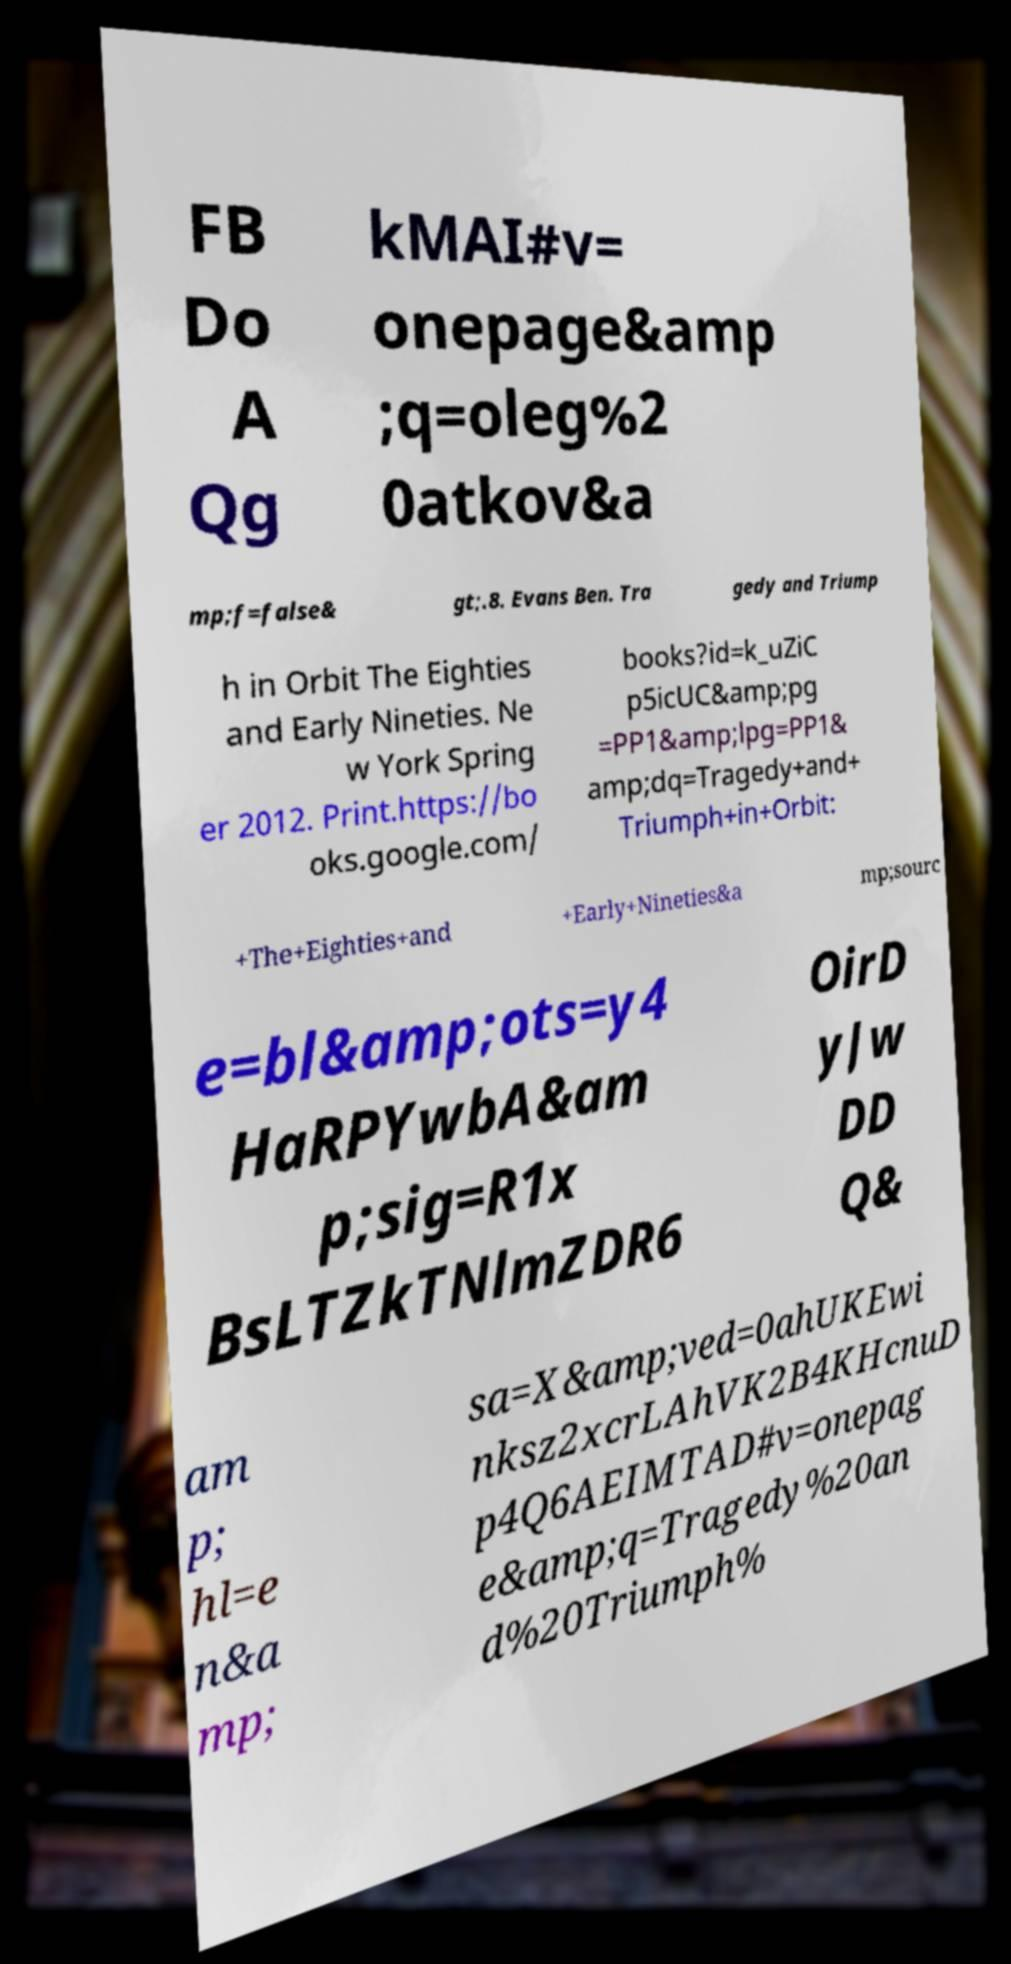Can you read and provide the text displayed in the image?This photo seems to have some interesting text. Can you extract and type it out for me? FB Do A Qg kMAI#v= onepage&amp ;q=oleg%2 0atkov&a mp;f=false& gt;.8. Evans Ben. Tra gedy and Triump h in Orbit The Eighties and Early Nineties. Ne w York Spring er 2012. Print.https://bo oks.google.com/ books?id=k_uZiC p5icUC&amp;pg =PP1&amp;lpg=PP1& amp;dq=Tragedy+and+ Triumph+in+Orbit: +The+Eighties+and +Early+Nineties&a mp;sourc e=bl&amp;ots=y4 HaRPYwbA&am p;sig=R1x BsLTZkTNlmZDR6 OirD yJw DD Q& am p; hl=e n&a mp; sa=X&amp;ved=0ahUKEwi nksz2xcrLAhVK2B4KHcnuD p4Q6AEIMTAD#v=onepag e&amp;q=Tragedy%20an d%20Triumph% 